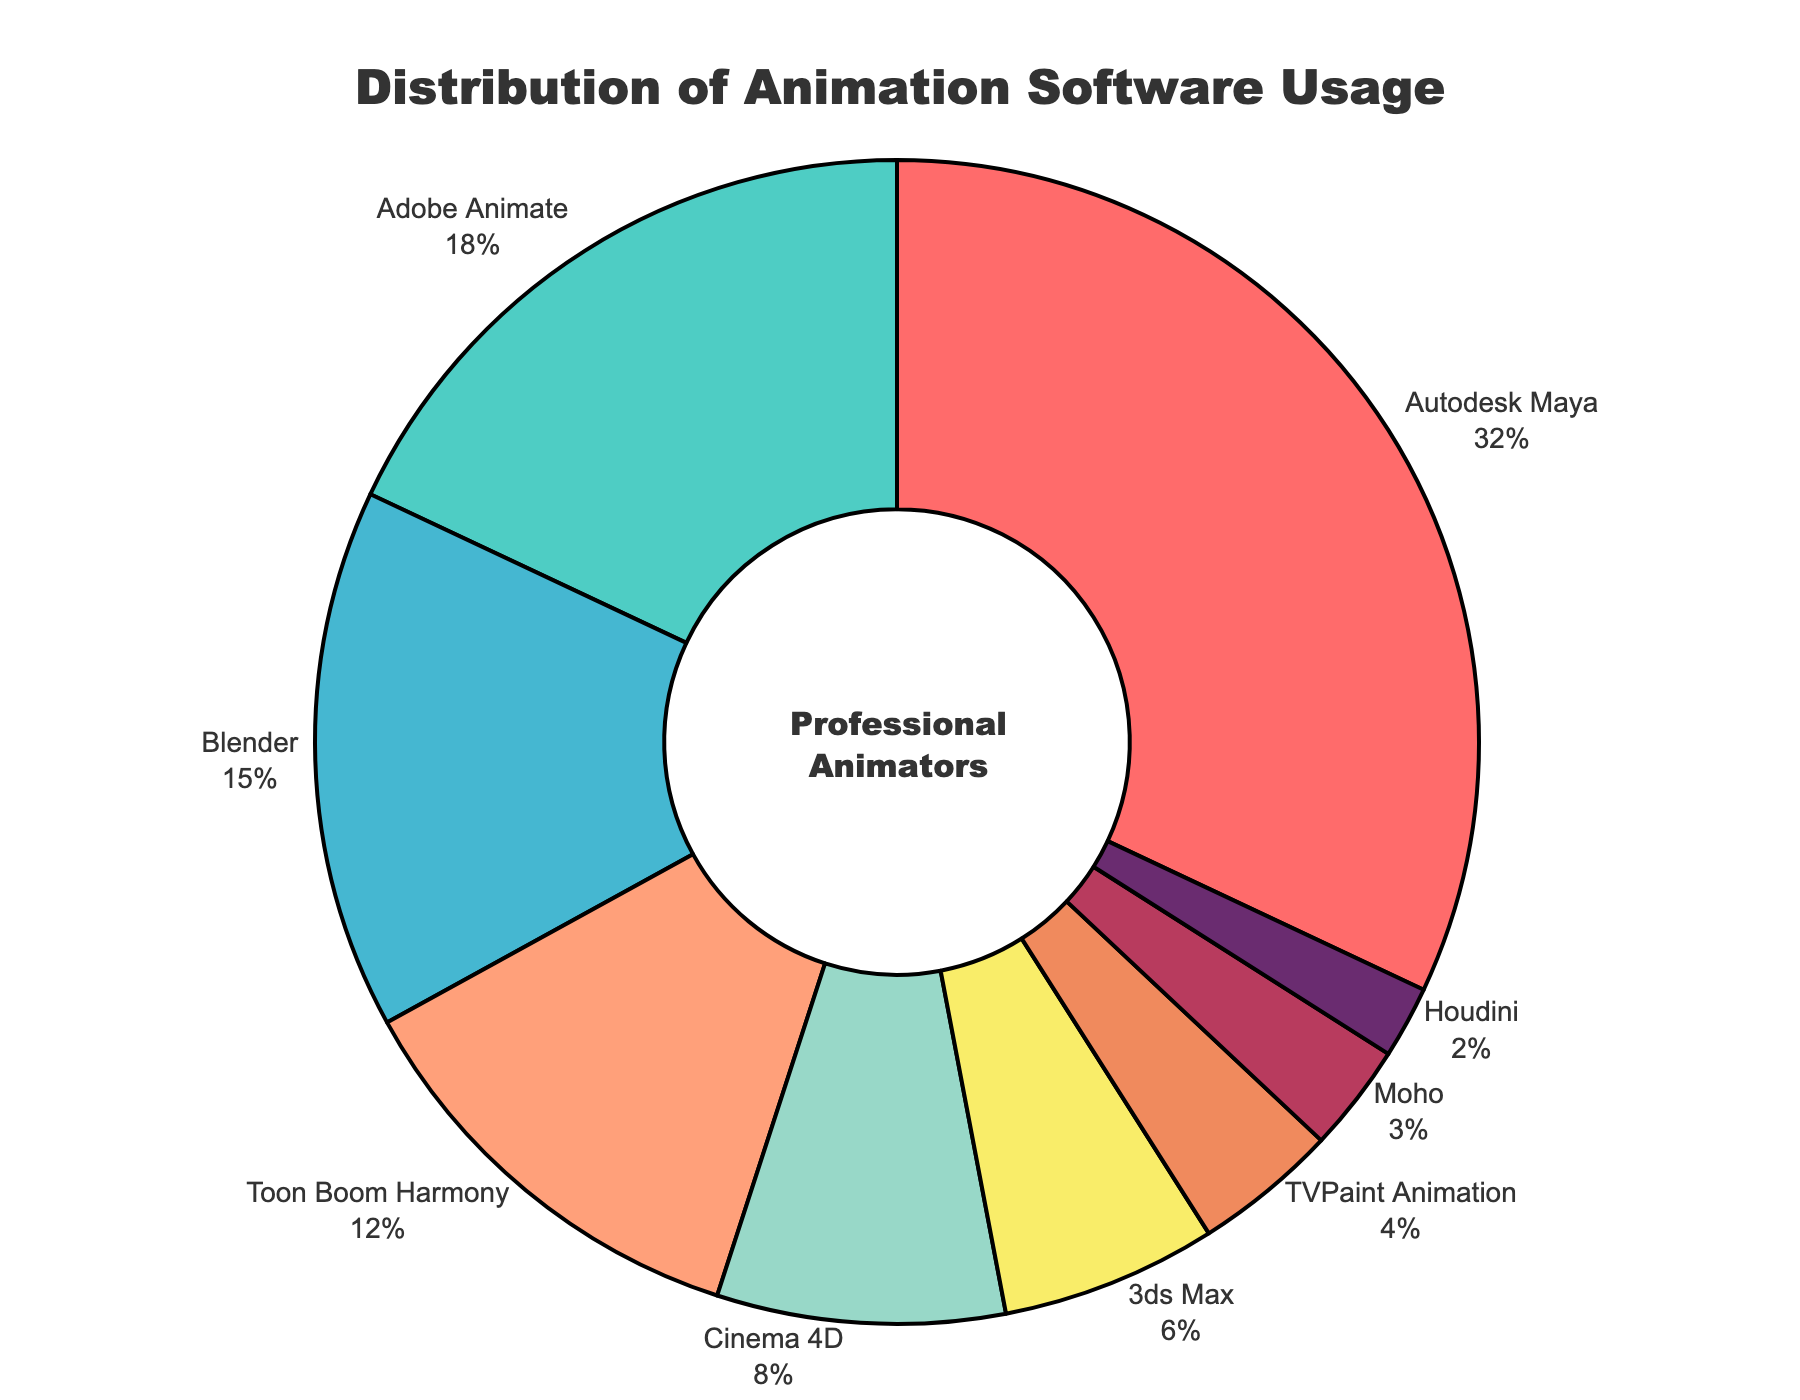What is the distribution of software usage among professional animators? The pie chart shows different software and their percentages of usage. Each slice represents a different software with its respective usage percentage.
Answer: Autodesk Maya (32%), Adobe Animate (18%), Blender (15%), Toon Boom Harmony (12%), Cinema 4D (8%), 3ds Max (6%), TVPaint Animation (4%), Moho (3%), Houdini (2%) Which software has the highest usage among professional animators? By examining the pie chart, the largest slice represents Autodesk Maya.
Answer: Autodesk Maya How much more usage does Autodesk Maya have compared to Blender? Autodesk Maya has 32% usage, and Blender has 15% usage. The difference is calculated as 32% - 15% = 17%.
Answer: 17% What percentage of animators use either TVPaint Animation or Moho? TVPaint Animation has 4%, and Moho has 3%. The sum is 4% + 3% = 7%.
Answer: 7% How does the usage of Cinema 4D compare to 3ds Max? Cinema 4D has 8% usage, and 3ds Max has 6% usage. Cinema 4D's usage is higher by 8% - 6% = 2%.
Answer: Cinema 4D has 2% more usage than 3ds Max Which software usage lies between Blender and Adobe Animate in terms of percentage? Blender has 15% usage, and Adobe Animate has 18% usage. The usage of Toon Boom Harmony, which is 12%, lies between these two percentages.
Answer: Toon Boom Harmony What is the least used software among the professional animators? The smallest slice in the pie chart represents Houdini, showing it as the least used software.
Answer: Houdini Visualize the segment representing Blender's usage. Which color represents it? By observing the pie chart, Blender's segment is represented by a blue color in the chart.
Answer: Blue What is the combined usage percentage of Toon Boom Harmony and Cinema 4D? Toon Boom Harmony has 12% usage and Cinema 4D has 8% usage. Combined, their usage is 12% + 8% = 20%.
Answer: 20% Is Autodesk Maya usage more than the combined usage of Adobe Animate and Blender? Autodesk Maya has 32% usage. Adobe Animate has 18%, and Blender has 15%. Combined, Adobe Animate and Blender have 18% + 15% = 33%. Since 33% is greater than 32%, Autodesk Maya has less usage.
Answer: No 